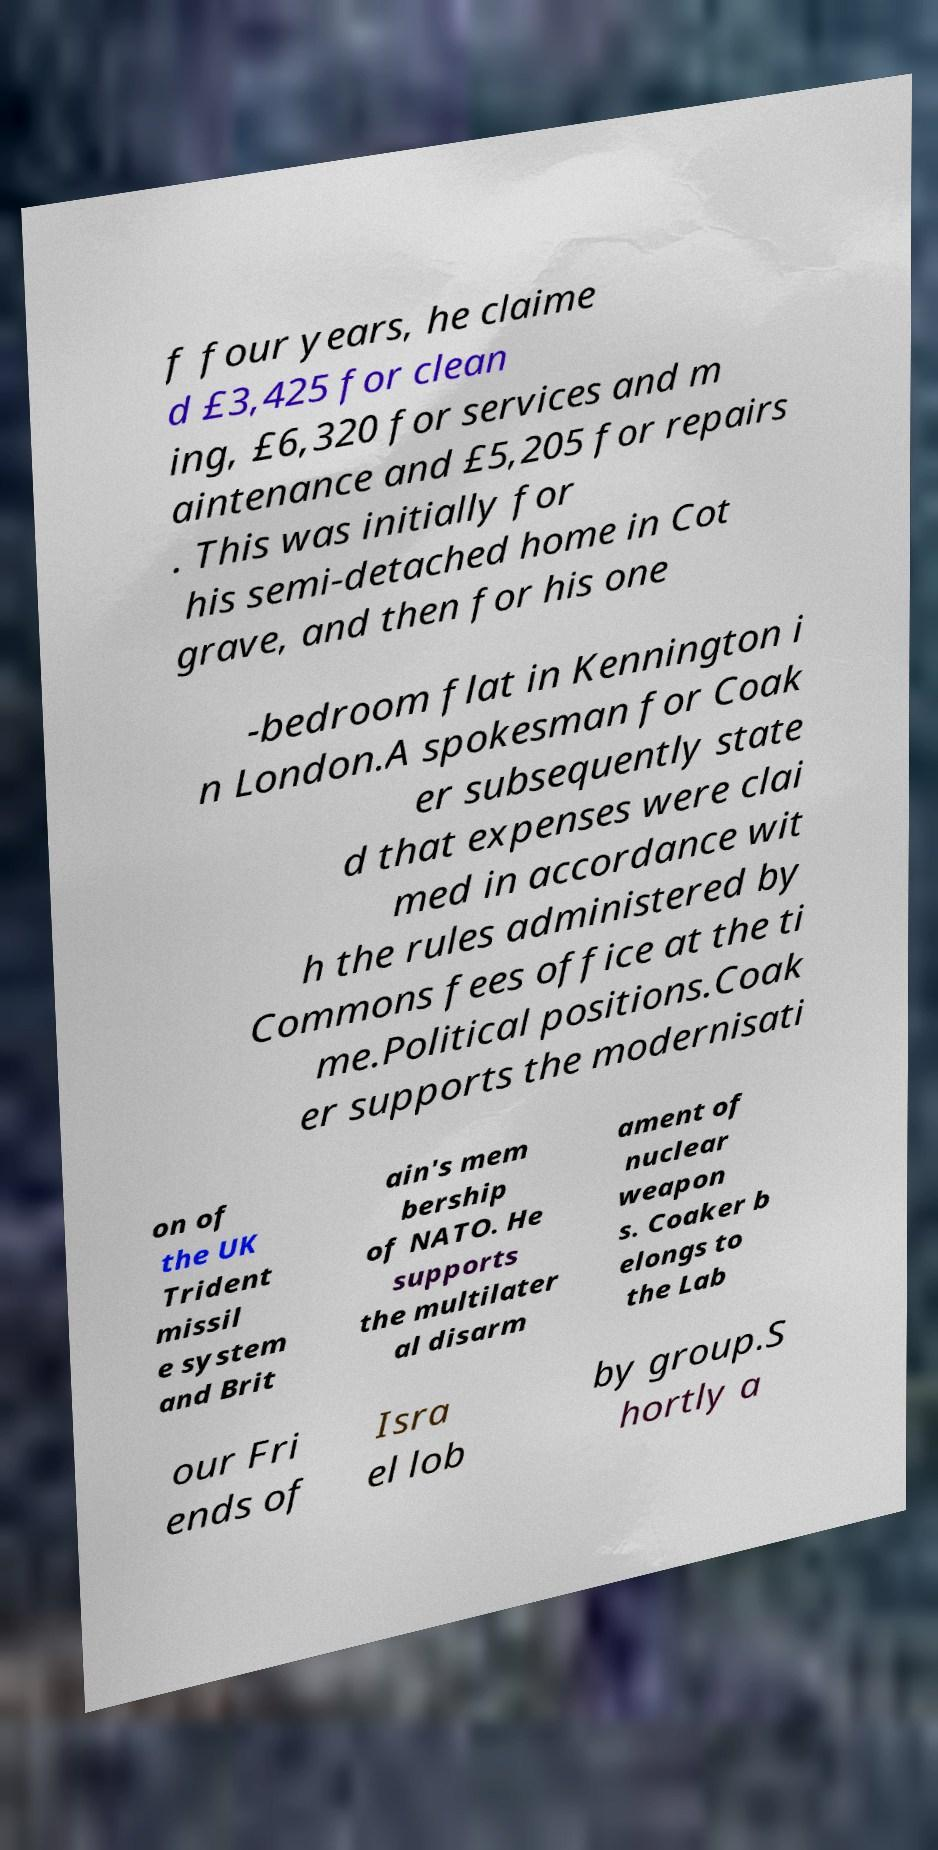Could you extract and type out the text from this image? f four years, he claime d £3,425 for clean ing, £6,320 for services and m aintenance and £5,205 for repairs . This was initially for his semi-detached home in Cot grave, and then for his one -bedroom flat in Kennington i n London.A spokesman for Coak er subsequently state d that expenses were clai med in accordance wit h the rules administered by Commons fees office at the ti me.Political positions.Coak er supports the modernisati on of the UK Trident missil e system and Brit ain's mem bership of NATO. He supports the multilater al disarm ament of nuclear weapon s. Coaker b elongs to the Lab our Fri ends of Isra el lob by group.S hortly a 